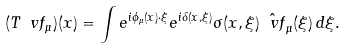Convert formula to latex. <formula><loc_0><loc_0><loc_500><loc_500>( T \ v f _ { \mu } ) ( x ) = \int e ^ { i \phi _ { \mu } ( x ) \cdot \xi } e ^ { i \delta ( x , \xi ) } \sigma ( x , \xi ) \hat { \ v f } _ { \mu } ( \xi ) \, d \xi .</formula> 